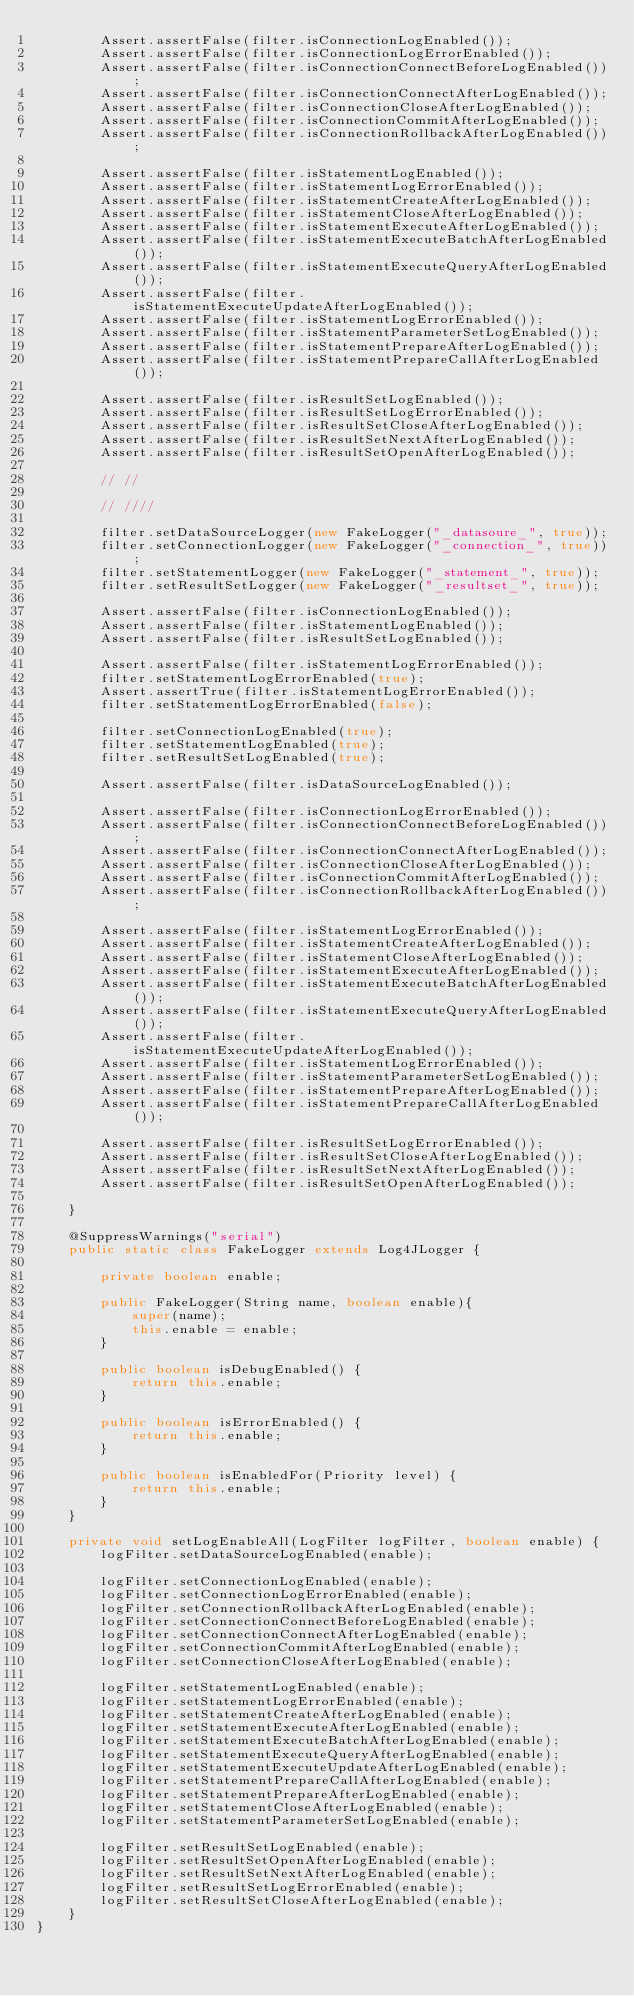<code> <loc_0><loc_0><loc_500><loc_500><_Java_>        Assert.assertFalse(filter.isConnectionLogEnabled());
        Assert.assertFalse(filter.isConnectionLogErrorEnabled());
        Assert.assertFalse(filter.isConnectionConnectBeforeLogEnabled());
        Assert.assertFalse(filter.isConnectionConnectAfterLogEnabled());
        Assert.assertFalse(filter.isConnectionCloseAfterLogEnabled());
        Assert.assertFalse(filter.isConnectionCommitAfterLogEnabled());
        Assert.assertFalse(filter.isConnectionRollbackAfterLogEnabled());

        Assert.assertFalse(filter.isStatementLogEnabled());
        Assert.assertFalse(filter.isStatementLogErrorEnabled());
        Assert.assertFalse(filter.isStatementCreateAfterLogEnabled());
        Assert.assertFalse(filter.isStatementCloseAfterLogEnabled());
        Assert.assertFalse(filter.isStatementExecuteAfterLogEnabled());
        Assert.assertFalse(filter.isStatementExecuteBatchAfterLogEnabled());
        Assert.assertFalse(filter.isStatementExecuteQueryAfterLogEnabled());
        Assert.assertFalse(filter.isStatementExecuteUpdateAfterLogEnabled());
        Assert.assertFalse(filter.isStatementLogErrorEnabled());
        Assert.assertFalse(filter.isStatementParameterSetLogEnabled());
        Assert.assertFalse(filter.isStatementPrepareAfterLogEnabled());
        Assert.assertFalse(filter.isStatementPrepareCallAfterLogEnabled());

        Assert.assertFalse(filter.isResultSetLogEnabled());
        Assert.assertFalse(filter.isResultSetLogErrorEnabled());
        Assert.assertFalse(filter.isResultSetCloseAfterLogEnabled());
        Assert.assertFalse(filter.isResultSetNextAfterLogEnabled());
        Assert.assertFalse(filter.isResultSetOpenAfterLogEnabled());

        // //

        // ////

        filter.setDataSourceLogger(new FakeLogger("_datasoure_", true));
        filter.setConnectionLogger(new FakeLogger("_connection_", true));
        filter.setStatementLogger(new FakeLogger("_statement_", true));
        filter.setResultSetLogger(new FakeLogger("_resultset_", true));

        Assert.assertFalse(filter.isConnectionLogEnabled());
        Assert.assertFalse(filter.isStatementLogEnabled());
        Assert.assertFalse(filter.isResultSetLogEnabled());

        Assert.assertFalse(filter.isStatementLogErrorEnabled());
        filter.setStatementLogErrorEnabled(true);
        Assert.assertTrue(filter.isStatementLogErrorEnabled());
        filter.setStatementLogErrorEnabled(false);

        filter.setConnectionLogEnabled(true);
        filter.setStatementLogEnabled(true);
        filter.setResultSetLogEnabled(true);

        Assert.assertFalse(filter.isDataSourceLogEnabled());

        Assert.assertFalse(filter.isConnectionLogErrorEnabled());
        Assert.assertFalse(filter.isConnectionConnectBeforeLogEnabled());
        Assert.assertFalse(filter.isConnectionConnectAfterLogEnabled());
        Assert.assertFalse(filter.isConnectionCloseAfterLogEnabled());
        Assert.assertFalse(filter.isConnectionCommitAfterLogEnabled());
        Assert.assertFalse(filter.isConnectionRollbackAfterLogEnabled());

        Assert.assertFalse(filter.isStatementLogErrorEnabled());
        Assert.assertFalse(filter.isStatementCreateAfterLogEnabled());
        Assert.assertFalse(filter.isStatementCloseAfterLogEnabled());
        Assert.assertFalse(filter.isStatementExecuteAfterLogEnabled());
        Assert.assertFalse(filter.isStatementExecuteBatchAfterLogEnabled());
        Assert.assertFalse(filter.isStatementExecuteQueryAfterLogEnabled());
        Assert.assertFalse(filter.isStatementExecuteUpdateAfterLogEnabled());
        Assert.assertFalse(filter.isStatementLogErrorEnabled());
        Assert.assertFalse(filter.isStatementParameterSetLogEnabled());
        Assert.assertFalse(filter.isStatementPrepareAfterLogEnabled());
        Assert.assertFalse(filter.isStatementPrepareCallAfterLogEnabled());

        Assert.assertFalse(filter.isResultSetLogErrorEnabled());
        Assert.assertFalse(filter.isResultSetCloseAfterLogEnabled());
        Assert.assertFalse(filter.isResultSetNextAfterLogEnabled());
        Assert.assertFalse(filter.isResultSetOpenAfterLogEnabled());

    }

    @SuppressWarnings("serial")
    public static class FakeLogger extends Log4JLogger {

        private boolean enable;

        public FakeLogger(String name, boolean enable){
            super(name);
            this.enable = enable;
        }

        public boolean isDebugEnabled() {
            return this.enable;
        }

        public boolean isErrorEnabled() {
            return this.enable;
        }

        public boolean isEnabledFor(Priority level) {
            return this.enable;
        }
    }

    private void setLogEnableAll(LogFilter logFilter, boolean enable) {
        logFilter.setDataSourceLogEnabled(enable);

        logFilter.setConnectionLogEnabled(enable);
        logFilter.setConnectionLogErrorEnabled(enable);
        logFilter.setConnectionRollbackAfterLogEnabled(enable);
        logFilter.setConnectionConnectBeforeLogEnabled(enable);
        logFilter.setConnectionConnectAfterLogEnabled(enable);
        logFilter.setConnectionCommitAfterLogEnabled(enable);
        logFilter.setConnectionCloseAfterLogEnabled(enable);

        logFilter.setStatementLogEnabled(enable);
        logFilter.setStatementLogErrorEnabled(enable);
        logFilter.setStatementCreateAfterLogEnabled(enable);
        logFilter.setStatementExecuteAfterLogEnabled(enable);
        logFilter.setStatementExecuteBatchAfterLogEnabled(enable);
        logFilter.setStatementExecuteQueryAfterLogEnabled(enable);
        logFilter.setStatementExecuteUpdateAfterLogEnabled(enable);
        logFilter.setStatementPrepareCallAfterLogEnabled(enable);
        logFilter.setStatementPrepareAfterLogEnabled(enable);
        logFilter.setStatementCloseAfterLogEnabled(enable);
        logFilter.setStatementParameterSetLogEnabled(enable);

        logFilter.setResultSetLogEnabled(enable);
        logFilter.setResultSetOpenAfterLogEnabled(enable);
        logFilter.setResultSetNextAfterLogEnabled(enable);
        logFilter.setResultSetLogErrorEnabled(enable);
        logFilter.setResultSetCloseAfterLogEnabled(enable);
    }
}
</code> 